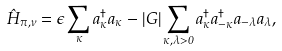<formula> <loc_0><loc_0><loc_500><loc_500>\hat { H } _ { \pi , \nu } = \epsilon \sum _ { \kappa } a ^ { \dagger } _ { \kappa } a _ { \kappa } - | G | \sum _ { \kappa , \lambda > 0 } a ^ { \dagger } _ { \kappa } a ^ { \dagger } _ { - \kappa } a _ { - \lambda } a _ { \lambda } ,</formula> 